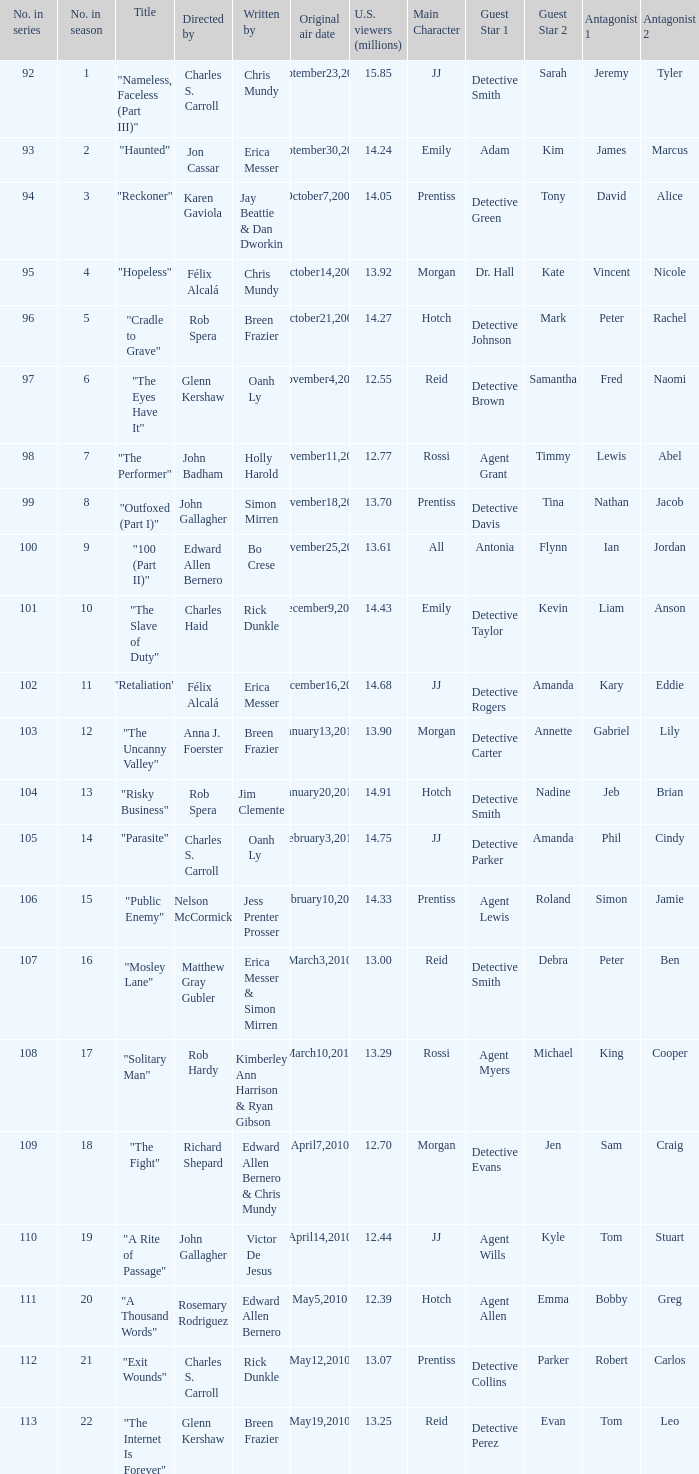What number(s) in the series was written by bo crese? 100.0. 